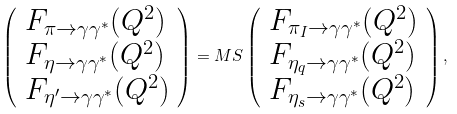<formula> <loc_0><loc_0><loc_500><loc_500>\left ( \begin{array} { l } F _ { \pi \rightarrow \gamma \gamma ^ { * } } ( Q ^ { 2 } ) \\ F _ { \eta \rightarrow \gamma \gamma ^ { * } } ( Q ^ { 2 } ) \\ F _ { \eta ^ { \prime } \rightarrow \gamma \gamma ^ { * } } ( Q ^ { 2 } ) \end{array} \right ) = M S \left ( \begin{array} { l } F _ { \pi _ { I } \rightarrow \gamma \gamma ^ { * } } ( Q ^ { 2 } ) \\ F _ { \eta _ { q } \rightarrow \gamma \gamma ^ { * } } ( Q ^ { 2 } ) \\ F _ { \eta _ { s } \rightarrow \gamma \gamma ^ { * } } ( Q ^ { 2 } ) \end{array} \right ) ,</formula> 